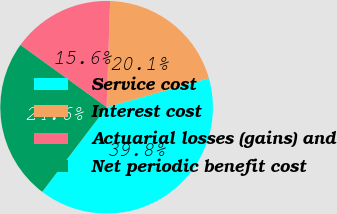Convert chart. <chart><loc_0><loc_0><loc_500><loc_500><pie_chart><fcel>Service cost<fcel>Interest cost<fcel>Actuarial losses (gains) and<fcel>Net periodic benefit cost<nl><fcel>39.75%<fcel>20.08%<fcel>15.57%<fcel>24.59%<nl></chart> 